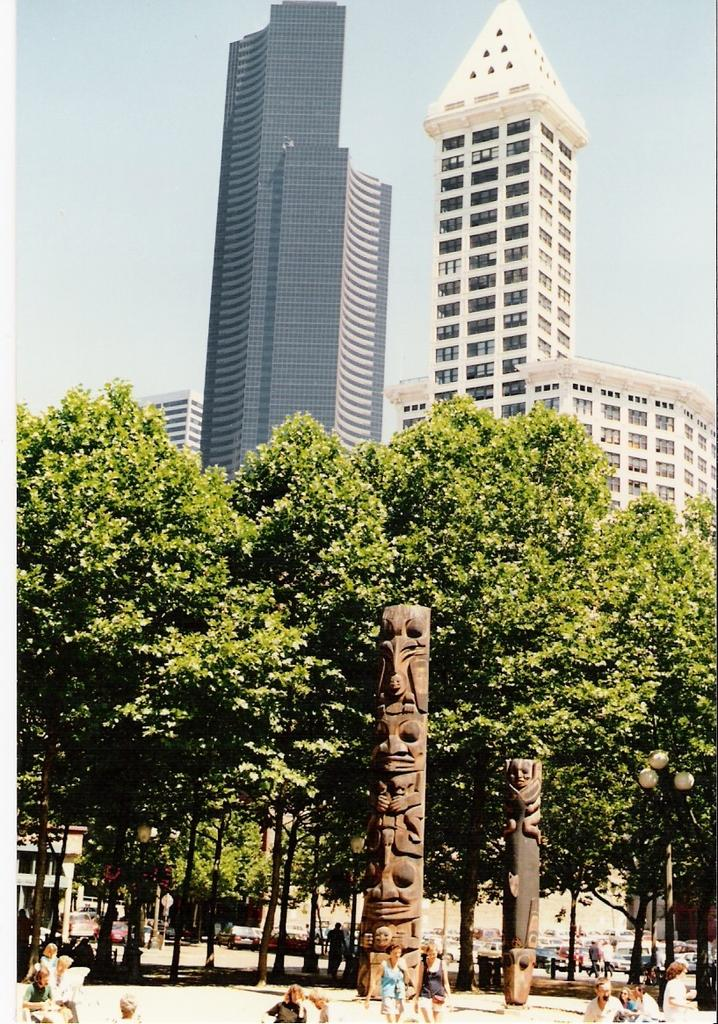What can be seen on the pillars in the image? There are sculptures on the pillars in the image. How many people are present in the image? There are many people in the image. What can be seen in the background of the image? There are trees, buildings, and the sky visible in the background of the image. Can you read the note that the cats are passing around in the image? There are no cats or notes present in the image. What type of attempt can be seen being made by the cats in the image? There are no cats or attempts present in the image. 